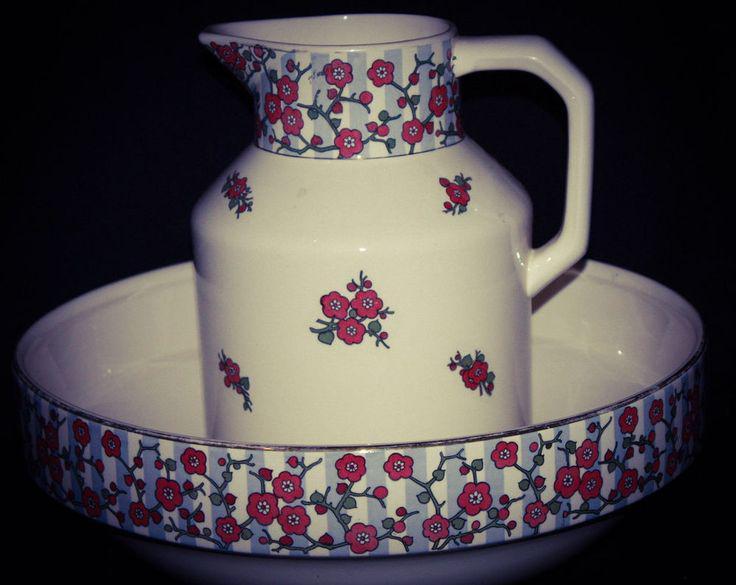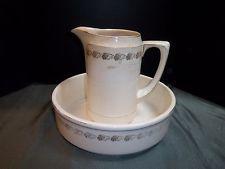The first image is the image on the left, the second image is the image on the right. Considering the images on both sides, is "One of two bowl and pitcher sets is predominantly white with only a pattern on the upper edge of the pitcher and the bowl." valid? Answer yes or no. Yes. 